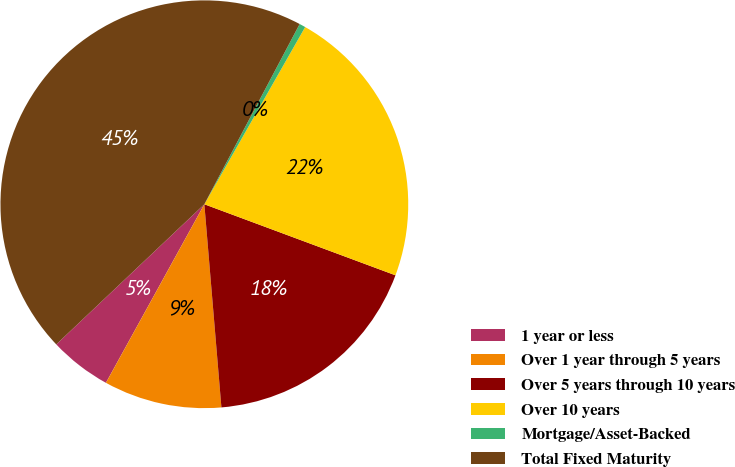Convert chart to OTSL. <chart><loc_0><loc_0><loc_500><loc_500><pie_chart><fcel>1 year or less<fcel>Over 1 year through 5 years<fcel>Over 5 years through 10 years<fcel>Over 10 years<fcel>Mortgage/Asset-Backed<fcel>Total Fixed Maturity<nl><fcel>4.92%<fcel>9.35%<fcel>18.0%<fcel>22.43%<fcel>0.49%<fcel>44.8%<nl></chart> 